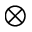<formula> <loc_0><loc_0><loc_500><loc_500>\otimes</formula> 